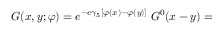<formula> <loc_0><loc_0><loc_500><loc_500>G ( x , y ; \varphi ) = e ^ { - e \gamma _ { 5 } [ \varphi ( x ) - \varphi ( y ) ] } \, G ^ { 0 } ( x - y ) =</formula> 